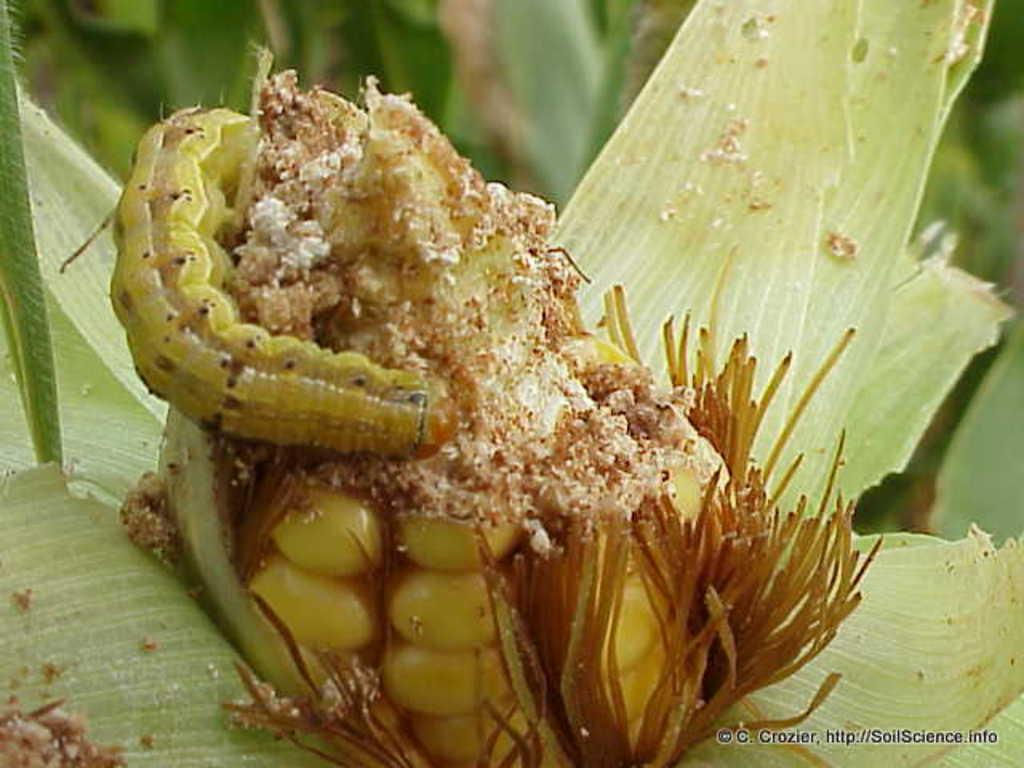What is on the corn in the image? There is an insect on the corn in the image. Can you describe the appearance of the insect? The insect has green and brown colors. What can be seen in the background of the image? There are many trees in the background of the image. How does the insect fold its wings in the image? The image does not show the insect folding its wings, so we cannot determine how it folds its wings from the image. 